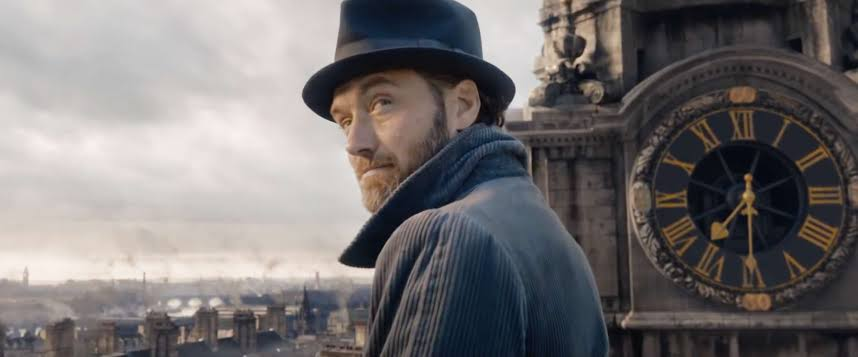What kind of emotions does the person's expression convey? The individual's expression appears pensive and serious, suggesting deep thought or concern. The way they are looking off to the side might indicate they are contemplating a significant matter or observing something intently. 